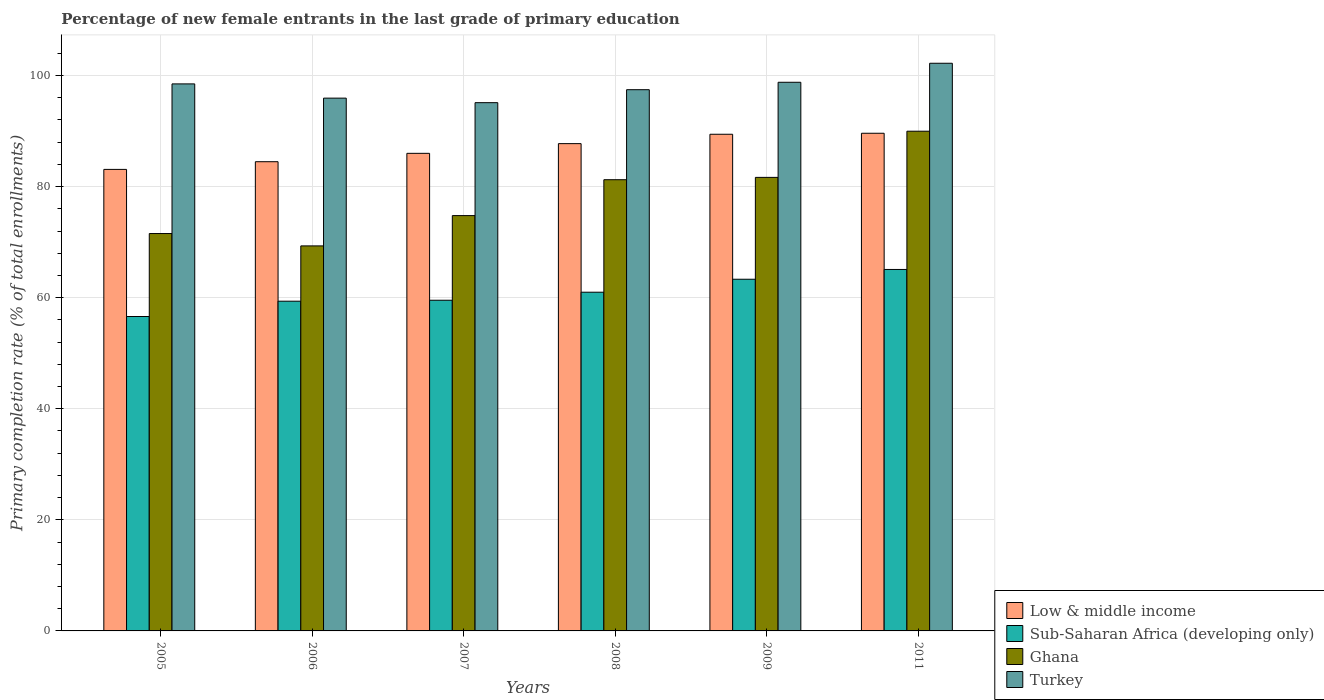Are the number of bars on each tick of the X-axis equal?
Offer a very short reply. Yes. How many bars are there on the 3rd tick from the left?
Give a very brief answer. 4. How many bars are there on the 2nd tick from the right?
Your answer should be compact. 4. What is the label of the 3rd group of bars from the left?
Make the answer very short. 2007. In how many cases, is the number of bars for a given year not equal to the number of legend labels?
Offer a terse response. 0. What is the percentage of new female entrants in Low & middle income in 2006?
Offer a very short reply. 84.48. Across all years, what is the maximum percentage of new female entrants in Low & middle income?
Your answer should be very brief. 89.6. Across all years, what is the minimum percentage of new female entrants in Turkey?
Offer a very short reply. 95.11. In which year was the percentage of new female entrants in Turkey minimum?
Give a very brief answer. 2007. What is the total percentage of new female entrants in Low & middle income in the graph?
Your answer should be very brief. 520.33. What is the difference between the percentage of new female entrants in Turkey in 2007 and that in 2009?
Your answer should be compact. -3.67. What is the difference between the percentage of new female entrants in Turkey in 2008 and the percentage of new female entrants in Low & middle income in 2005?
Provide a succinct answer. 14.35. What is the average percentage of new female entrants in Low & middle income per year?
Your response must be concise. 86.72. In the year 2008, what is the difference between the percentage of new female entrants in Low & middle income and percentage of new female entrants in Sub-Saharan Africa (developing only)?
Provide a short and direct response. 26.75. What is the ratio of the percentage of new female entrants in Ghana in 2005 to that in 2011?
Provide a short and direct response. 0.8. Is the difference between the percentage of new female entrants in Low & middle income in 2007 and 2008 greater than the difference between the percentage of new female entrants in Sub-Saharan Africa (developing only) in 2007 and 2008?
Keep it short and to the point. No. What is the difference between the highest and the second highest percentage of new female entrants in Sub-Saharan Africa (developing only)?
Ensure brevity in your answer.  1.76. What is the difference between the highest and the lowest percentage of new female entrants in Turkey?
Keep it short and to the point. 7.1. Is the sum of the percentage of new female entrants in Low & middle income in 2005 and 2008 greater than the maximum percentage of new female entrants in Ghana across all years?
Your answer should be compact. Yes. What does the 1st bar from the left in 2009 represents?
Your answer should be very brief. Low & middle income. How many bars are there?
Your answer should be very brief. 24. Are all the bars in the graph horizontal?
Your response must be concise. No. How many years are there in the graph?
Provide a succinct answer. 6. What is the difference between two consecutive major ticks on the Y-axis?
Ensure brevity in your answer.  20. Does the graph contain any zero values?
Provide a succinct answer. No. How are the legend labels stacked?
Keep it short and to the point. Vertical. What is the title of the graph?
Your answer should be very brief. Percentage of new female entrants in the last grade of primary education. What is the label or title of the X-axis?
Offer a very short reply. Years. What is the label or title of the Y-axis?
Offer a terse response. Primary completion rate (% of total enrollments). What is the Primary completion rate (% of total enrollments) in Low & middle income in 2005?
Offer a terse response. 83.1. What is the Primary completion rate (% of total enrollments) in Sub-Saharan Africa (developing only) in 2005?
Ensure brevity in your answer.  56.61. What is the Primary completion rate (% of total enrollments) in Ghana in 2005?
Give a very brief answer. 71.55. What is the Primary completion rate (% of total enrollments) of Turkey in 2005?
Your response must be concise. 98.49. What is the Primary completion rate (% of total enrollments) of Low & middle income in 2006?
Your answer should be very brief. 84.48. What is the Primary completion rate (% of total enrollments) in Sub-Saharan Africa (developing only) in 2006?
Offer a terse response. 59.37. What is the Primary completion rate (% of total enrollments) in Ghana in 2006?
Your response must be concise. 69.32. What is the Primary completion rate (% of total enrollments) of Turkey in 2006?
Offer a terse response. 95.93. What is the Primary completion rate (% of total enrollments) of Low & middle income in 2007?
Offer a terse response. 85.99. What is the Primary completion rate (% of total enrollments) in Sub-Saharan Africa (developing only) in 2007?
Offer a terse response. 59.54. What is the Primary completion rate (% of total enrollments) in Ghana in 2007?
Offer a very short reply. 74.78. What is the Primary completion rate (% of total enrollments) of Turkey in 2007?
Ensure brevity in your answer.  95.11. What is the Primary completion rate (% of total enrollments) in Low & middle income in 2008?
Offer a terse response. 87.74. What is the Primary completion rate (% of total enrollments) in Sub-Saharan Africa (developing only) in 2008?
Keep it short and to the point. 60.99. What is the Primary completion rate (% of total enrollments) in Ghana in 2008?
Your answer should be very brief. 81.24. What is the Primary completion rate (% of total enrollments) of Turkey in 2008?
Offer a very short reply. 97.45. What is the Primary completion rate (% of total enrollments) in Low & middle income in 2009?
Make the answer very short. 89.42. What is the Primary completion rate (% of total enrollments) of Sub-Saharan Africa (developing only) in 2009?
Keep it short and to the point. 63.32. What is the Primary completion rate (% of total enrollments) in Ghana in 2009?
Your response must be concise. 81.66. What is the Primary completion rate (% of total enrollments) of Turkey in 2009?
Offer a very short reply. 98.78. What is the Primary completion rate (% of total enrollments) of Low & middle income in 2011?
Provide a succinct answer. 89.6. What is the Primary completion rate (% of total enrollments) in Sub-Saharan Africa (developing only) in 2011?
Provide a short and direct response. 65.08. What is the Primary completion rate (% of total enrollments) of Ghana in 2011?
Provide a succinct answer. 89.97. What is the Primary completion rate (% of total enrollments) of Turkey in 2011?
Ensure brevity in your answer.  102.21. Across all years, what is the maximum Primary completion rate (% of total enrollments) of Low & middle income?
Provide a succinct answer. 89.6. Across all years, what is the maximum Primary completion rate (% of total enrollments) in Sub-Saharan Africa (developing only)?
Your response must be concise. 65.08. Across all years, what is the maximum Primary completion rate (% of total enrollments) of Ghana?
Offer a terse response. 89.97. Across all years, what is the maximum Primary completion rate (% of total enrollments) in Turkey?
Your answer should be very brief. 102.21. Across all years, what is the minimum Primary completion rate (% of total enrollments) of Low & middle income?
Provide a short and direct response. 83.1. Across all years, what is the minimum Primary completion rate (% of total enrollments) in Sub-Saharan Africa (developing only)?
Your answer should be compact. 56.61. Across all years, what is the minimum Primary completion rate (% of total enrollments) of Ghana?
Your response must be concise. 69.32. Across all years, what is the minimum Primary completion rate (% of total enrollments) in Turkey?
Your response must be concise. 95.11. What is the total Primary completion rate (% of total enrollments) in Low & middle income in the graph?
Offer a very short reply. 520.33. What is the total Primary completion rate (% of total enrollments) in Sub-Saharan Africa (developing only) in the graph?
Keep it short and to the point. 364.9. What is the total Primary completion rate (% of total enrollments) of Ghana in the graph?
Ensure brevity in your answer.  468.52. What is the total Primary completion rate (% of total enrollments) of Turkey in the graph?
Ensure brevity in your answer.  587.97. What is the difference between the Primary completion rate (% of total enrollments) of Low & middle income in 2005 and that in 2006?
Offer a terse response. -1.38. What is the difference between the Primary completion rate (% of total enrollments) in Sub-Saharan Africa (developing only) in 2005 and that in 2006?
Provide a short and direct response. -2.76. What is the difference between the Primary completion rate (% of total enrollments) of Ghana in 2005 and that in 2006?
Give a very brief answer. 2.22. What is the difference between the Primary completion rate (% of total enrollments) in Turkey in 2005 and that in 2006?
Your answer should be compact. 2.56. What is the difference between the Primary completion rate (% of total enrollments) of Low & middle income in 2005 and that in 2007?
Offer a terse response. -2.89. What is the difference between the Primary completion rate (% of total enrollments) of Sub-Saharan Africa (developing only) in 2005 and that in 2007?
Give a very brief answer. -2.93. What is the difference between the Primary completion rate (% of total enrollments) in Ghana in 2005 and that in 2007?
Offer a terse response. -3.23. What is the difference between the Primary completion rate (% of total enrollments) in Turkey in 2005 and that in 2007?
Provide a succinct answer. 3.38. What is the difference between the Primary completion rate (% of total enrollments) in Low & middle income in 2005 and that in 2008?
Give a very brief answer. -4.64. What is the difference between the Primary completion rate (% of total enrollments) of Sub-Saharan Africa (developing only) in 2005 and that in 2008?
Offer a terse response. -4.38. What is the difference between the Primary completion rate (% of total enrollments) in Ghana in 2005 and that in 2008?
Offer a very short reply. -9.69. What is the difference between the Primary completion rate (% of total enrollments) in Turkey in 2005 and that in 2008?
Offer a very short reply. 1.04. What is the difference between the Primary completion rate (% of total enrollments) in Low & middle income in 2005 and that in 2009?
Your answer should be very brief. -6.33. What is the difference between the Primary completion rate (% of total enrollments) in Sub-Saharan Africa (developing only) in 2005 and that in 2009?
Your response must be concise. -6.71. What is the difference between the Primary completion rate (% of total enrollments) of Ghana in 2005 and that in 2009?
Provide a succinct answer. -10.11. What is the difference between the Primary completion rate (% of total enrollments) in Turkey in 2005 and that in 2009?
Offer a very short reply. -0.29. What is the difference between the Primary completion rate (% of total enrollments) in Low & middle income in 2005 and that in 2011?
Offer a terse response. -6.51. What is the difference between the Primary completion rate (% of total enrollments) in Sub-Saharan Africa (developing only) in 2005 and that in 2011?
Keep it short and to the point. -8.47. What is the difference between the Primary completion rate (% of total enrollments) of Ghana in 2005 and that in 2011?
Your answer should be compact. -18.42. What is the difference between the Primary completion rate (% of total enrollments) of Turkey in 2005 and that in 2011?
Give a very brief answer. -3.72. What is the difference between the Primary completion rate (% of total enrollments) of Low & middle income in 2006 and that in 2007?
Offer a terse response. -1.51. What is the difference between the Primary completion rate (% of total enrollments) of Sub-Saharan Africa (developing only) in 2006 and that in 2007?
Your answer should be compact. -0.17. What is the difference between the Primary completion rate (% of total enrollments) of Ghana in 2006 and that in 2007?
Provide a succinct answer. -5.46. What is the difference between the Primary completion rate (% of total enrollments) in Turkey in 2006 and that in 2007?
Make the answer very short. 0.82. What is the difference between the Primary completion rate (% of total enrollments) in Low & middle income in 2006 and that in 2008?
Your answer should be very brief. -3.26. What is the difference between the Primary completion rate (% of total enrollments) of Sub-Saharan Africa (developing only) in 2006 and that in 2008?
Your answer should be compact. -1.62. What is the difference between the Primary completion rate (% of total enrollments) of Ghana in 2006 and that in 2008?
Ensure brevity in your answer.  -11.92. What is the difference between the Primary completion rate (% of total enrollments) of Turkey in 2006 and that in 2008?
Make the answer very short. -1.52. What is the difference between the Primary completion rate (% of total enrollments) in Low & middle income in 2006 and that in 2009?
Provide a short and direct response. -4.94. What is the difference between the Primary completion rate (% of total enrollments) of Sub-Saharan Africa (developing only) in 2006 and that in 2009?
Make the answer very short. -3.95. What is the difference between the Primary completion rate (% of total enrollments) in Ghana in 2006 and that in 2009?
Provide a succinct answer. -12.34. What is the difference between the Primary completion rate (% of total enrollments) in Turkey in 2006 and that in 2009?
Offer a very short reply. -2.86. What is the difference between the Primary completion rate (% of total enrollments) of Low & middle income in 2006 and that in 2011?
Your answer should be very brief. -5.12. What is the difference between the Primary completion rate (% of total enrollments) in Sub-Saharan Africa (developing only) in 2006 and that in 2011?
Your response must be concise. -5.71. What is the difference between the Primary completion rate (% of total enrollments) in Ghana in 2006 and that in 2011?
Your response must be concise. -20.65. What is the difference between the Primary completion rate (% of total enrollments) in Turkey in 2006 and that in 2011?
Provide a succinct answer. -6.28. What is the difference between the Primary completion rate (% of total enrollments) in Low & middle income in 2007 and that in 2008?
Keep it short and to the point. -1.75. What is the difference between the Primary completion rate (% of total enrollments) in Sub-Saharan Africa (developing only) in 2007 and that in 2008?
Ensure brevity in your answer.  -1.45. What is the difference between the Primary completion rate (% of total enrollments) of Ghana in 2007 and that in 2008?
Your answer should be very brief. -6.46. What is the difference between the Primary completion rate (% of total enrollments) of Turkey in 2007 and that in 2008?
Your answer should be compact. -2.34. What is the difference between the Primary completion rate (% of total enrollments) of Low & middle income in 2007 and that in 2009?
Offer a very short reply. -3.43. What is the difference between the Primary completion rate (% of total enrollments) in Sub-Saharan Africa (developing only) in 2007 and that in 2009?
Ensure brevity in your answer.  -3.78. What is the difference between the Primary completion rate (% of total enrollments) in Ghana in 2007 and that in 2009?
Offer a terse response. -6.88. What is the difference between the Primary completion rate (% of total enrollments) in Turkey in 2007 and that in 2009?
Your answer should be very brief. -3.67. What is the difference between the Primary completion rate (% of total enrollments) of Low & middle income in 2007 and that in 2011?
Make the answer very short. -3.61. What is the difference between the Primary completion rate (% of total enrollments) of Sub-Saharan Africa (developing only) in 2007 and that in 2011?
Offer a very short reply. -5.54. What is the difference between the Primary completion rate (% of total enrollments) in Ghana in 2007 and that in 2011?
Your answer should be very brief. -15.19. What is the difference between the Primary completion rate (% of total enrollments) in Turkey in 2007 and that in 2011?
Provide a short and direct response. -7.09. What is the difference between the Primary completion rate (% of total enrollments) in Low & middle income in 2008 and that in 2009?
Keep it short and to the point. -1.69. What is the difference between the Primary completion rate (% of total enrollments) in Sub-Saharan Africa (developing only) in 2008 and that in 2009?
Give a very brief answer. -2.33. What is the difference between the Primary completion rate (% of total enrollments) in Ghana in 2008 and that in 2009?
Your answer should be very brief. -0.42. What is the difference between the Primary completion rate (% of total enrollments) of Turkey in 2008 and that in 2009?
Ensure brevity in your answer.  -1.34. What is the difference between the Primary completion rate (% of total enrollments) of Low & middle income in 2008 and that in 2011?
Provide a succinct answer. -1.87. What is the difference between the Primary completion rate (% of total enrollments) in Sub-Saharan Africa (developing only) in 2008 and that in 2011?
Keep it short and to the point. -4.1. What is the difference between the Primary completion rate (% of total enrollments) of Ghana in 2008 and that in 2011?
Provide a short and direct response. -8.73. What is the difference between the Primary completion rate (% of total enrollments) in Turkey in 2008 and that in 2011?
Offer a terse response. -4.76. What is the difference between the Primary completion rate (% of total enrollments) in Low & middle income in 2009 and that in 2011?
Your response must be concise. -0.18. What is the difference between the Primary completion rate (% of total enrollments) in Sub-Saharan Africa (developing only) in 2009 and that in 2011?
Keep it short and to the point. -1.76. What is the difference between the Primary completion rate (% of total enrollments) in Ghana in 2009 and that in 2011?
Provide a short and direct response. -8.31. What is the difference between the Primary completion rate (% of total enrollments) of Turkey in 2009 and that in 2011?
Offer a terse response. -3.42. What is the difference between the Primary completion rate (% of total enrollments) in Low & middle income in 2005 and the Primary completion rate (% of total enrollments) in Sub-Saharan Africa (developing only) in 2006?
Your answer should be very brief. 23.73. What is the difference between the Primary completion rate (% of total enrollments) in Low & middle income in 2005 and the Primary completion rate (% of total enrollments) in Ghana in 2006?
Your answer should be compact. 13.77. What is the difference between the Primary completion rate (% of total enrollments) in Low & middle income in 2005 and the Primary completion rate (% of total enrollments) in Turkey in 2006?
Your answer should be compact. -12.83. What is the difference between the Primary completion rate (% of total enrollments) in Sub-Saharan Africa (developing only) in 2005 and the Primary completion rate (% of total enrollments) in Ghana in 2006?
Provide a short and direct response. -12.71. What is the difference between the Primary completion rate (% of total enrollments) in Sub-Saharan Africa (developing only) in 2005 and the Primary completion rate (% of total enrollments) in Turkey in 2006?
Your response must be concise. -39.32. What is the difference between the Primary completion rate (% of total enrollments) of Ghana in 2005 and the Primary completion rate (% of total enrollments) of Turkey in 2006?
Provide a short and direct response. -24.38. What is the difference between the Primary completion rate (% of total enrollments) in Low & middle income in 2005 and the Primary completion rate (% of total enrollments) in Sub-Saharan Africa (developing only) in 2007?
Give a very brief answer. 23.56. What is the difference between the Primary completion rate (% of total enrollments) of Low & middle income in 2005 and the Primary completion rate (% of total enrollments) of Ghana in 2007?
Keep it short and to the point. 8.32. What is the difference between the Primary completion rate (% of total enrollments) of Low & middle income in 2005 and the Primary completion rate (% of total enrollments) of Turkey in 2007?
Offer a very short reply. -12.01. What is the difference between the Primary completion rate (% of total enrollments) in Sub-Saharan Africa (developing only) in 2005 and the Primary completion rate (% of total enrollments) in Ghana in 2007?
Provide a succinct answer. -18.17. What is the difference between the Primary completion rate (% of total enrollments) of Sub-Saharan Africa (developing only) in 2005 and the Primary completion rate (% of total enrollments) of Turkey in 2007?
Provide a short and direct response. -38.5. What is the difference between the Primary completion rate (% of total enrollments) in Ghana in 2005 and the Primary completion rate (% of total enrollments) in Turkey in 2007?
Keep it short and to the point. -23.57. What is the difference between the Primary completion rate (% of total enrollments) of Low & middle income in 2005 and the Primary completion rate (% of total enrollments) of Sub-Saharan Africa (developing only) in 2008?
Your response must be concise. 22.11. What is the difference between the Primary completion rate (% of total enrollments) in Low & middle income in 2005 and the Primary completion rate (% of total enrollments) in Ghana in 2008?
Offer a terse response. 1.86. What is the difference between the Primary completion rate (% of total enrollments) in Low & middle income in 2005 and the Primary completion rate (% of total enrollments) in Turkey in 2008?
Make the answer very short. -14.35. What is the difference between the Primary completion rate (% of total enrollments) of Sub-Saharan Africa (developing only) in 2005 and the Primary completion rate (% of total enrollments) of Ghana in 2008?
Keep it short and to the point. -24.63. What is the difference between the Primary completion rate (% of total enrollments) of Sub-Saharan Africa (developing only) in 2005 and the Primary completion rate (% of total enrollments) of Turkey in 2008?
Give a very brief answer. -40.84. What is the difference between the Primary completion rate (% of total enrollments) in Ghana in 2005 and the Primary completion rate (% of total enrollments) in Turkey in 2008?
Your answer should be very brief. -25.9. What is the difference between the Primary completion rate (% of total enrollments) in Low & middle income in 2005 and the Primary completion rate (% of total enrollments) in Sub-Saharan Africa (developing only) in 2009?
Offer a very short reply. 19.78. What is the difference between the Primary completion rate (% of total enrollments) in Low & middle income in 2005 and the Primary completion rate (% of total enrollments) in Ghana in 2009?
Offer a very short reply. 1.44. What is the difference between the Primary completion rate (% of total enrollments) in Low & middle income in 2005 and the Primary completion rate (% of total enrollments) in Turkey in 2009?
Make the answer very short. -15.69. What is the difference between the Primary completion rate (% of total enrollments) of Sub-Saharan Africa (developing only) in 2005 and the Primary completion rate (% of total enrollments) of Ghana in 2009?
Give a very brief answer. -25.05. What is the difference between the Primary completion rate (% of total enrollments) in Sub-Saharan Africa (developing only) in 2005 and the Primary completion rate (% of total enrollments) in Turkey in 2009?
Your response must be concise. -42.18. What is the difference between the Primary completion rate (% of total enrollments) of Ghana in 2005 and the Primary completion rate (% of total enrollments) of Turkey in 2009?
Your answer should be very brief. -27.24. What is the difference between the Primary completion rate (% of total enrollments) in Low & middle income in 2005 and the Primary completion rate (% of total enrollments) in Sub-Saharan Africa (developing only) in 2011?
Offer a very short reply. 18.02. What is the difference between the Primary completion rate (% of total enrollments) in Low & middle income in 2005 and the Primary completion rate (% of total enrollments) in Ghana in 2011?
Make the answer very short. -6.87. What is the difference between the Primary completion rate (% of total enrollments) of Low & middle income in 2005 and the Primary completion rate (% of total enrollments) of Turkey in 2011?
Your response must be concise. -19.11. What is the difference between the Primary completion rate (% of total enrollments) in Sub-Saharan Africa (developing only) in 2005 and the Primary completion rate (% of total enrollments) in Ghana in 2011?
Your answer should be very brief. -33.36. What is the difference between the Primary completion rate (% of total enrollments) of Sub-Saharan Africa (developing only) in 2005 and the Primary completion rate (% of total enrollments) of Turkey in 2011?
Provide a short and direct response. -45.6. What is the difference between the Primary completion rate (% of total enrollments) in Ghana in 2005 and the Primary completion rate (% of total enrollments) in Turkey in 2011?
Ensure brevity in your answer.  -30.66. What is the difference between the Primary completion rate (% of total enrollments) in Low & middle income in 2006 and the Primary completion rate (% of total enrollments) in Sub-Saharan Africa (developing only) in 2007?
Offer a very short reply. 24.94. What is the difference between the Primary completion rate (% of total enrollments) of Low & middle income in 2006 and the Primary completion rate (% of total enrollments) of Ghana in 2007?
Provide a succinct answer. 9.7. What is the difference between the Primary completion rate (% of total enrollments) of Low & middle income in 2006 and the Primary completion rate (% of total enrollments) of Turkey in 2007?
Provide a short and direct response. -10.63. What is the difference between the Primary completion rate (% of total enrollments) in Sub-Saharan Africa (developing only) in 2006 and the Primary completion rate (% of total enrollments) in Ghana in 2007?
Keep it short and to the point. -15.41. What is the difference between the Primary completion rate (% of total enrollments) in Sub-Saharan Africa (developing only) in 2006 and the Primary completion rate (% of total enrollments) in Turkey in 2007?
Provide a succinct answer. -35.74. What is the difference between the Primary completion rate (% of total enrollments) in Ghana in 2006 and the Primary completion rate (% of total enrollments) in Turkey in 2007?
Offer a terse response. -25.79. What is the difference between the Primary completion rate (% of total enrollments) in Low & middle income in 2006 and the Primary completion rate (% of total enrollments) in Sub-Saharan Africa (developing only) in 2008?
Your answer should be compact. 23.49. What is the difference between the Primary completion rate (% of total enrollments) in Low & middle income in 2006 and the Primary completion rate (% of total enrollments) in Ghana in 2008?
Provide a short and direct response. 3.24. What is the difference between the Primary completion rate (% of total enrollments) in Low & middle income in 2006 and the Primary completion rate (% of total enrollments) in Turkey in 2008?
Provide a short and direct response. -12.97. What is the difference between the Primary completion rate (% of total enrollments) of Sub-Saharan Africa (developing only) in 2006 and the Primary completion rate (% of total enrollments) of Ghana in 2008?
Make the answer very short. -21.87. What is the difference between the Primary completion rate (% of total enrollments) of Sub-Saharan Africa (developing only) in 2006 and the Primary completion rate (% of total enrollments) of Turkey in 2008?
Ensure brevity in your answer.  -38.08. What is the difference between the Primary completion rate (% of total enrollments) of Ghana in 2006 and the Primary completion rate (% of total enrollments) of Turkey in 2008?
Give a very brief answer. -28.12. What is the difference between the Primary completion rate (% of total enrollments) of Low & middle income in 2006 and the Primary completion rate (% of total enrollments) of Sub-Saharan Africa (developing only) in 2009?
Your response must be concise. 21.16. What is the difference between the Primary completion rate (% of total enrollments) of Low & middle income in 2006 and the Primary completion rate (% of total enrollments) of Ghana in 2009?
Make the answer very short. 2.82. What is the difference between the Primary completion rate (% of total enrollments) in Low & middle income in 2006 and the Primary completion rate (% of total enrollments) in Turkey in 2009?
Offer a terse response. -14.3. What is the difference between the Primary completion rate (% of total enrollments) in Sub-Saharan Africa (developing only) in 2006 and the Primary completion rate (% of total enrollments) in Ghana in 2009?
Make the answer very short. -22.29. What is the difference between the Primary completion rate (% of total enrollments) of Sub-Saharan Africa (developing only) in 2006 and the Primary completion rate (% of total enrollments) of Turkey in 2009?
Offer a terse response. -39.42. What is the difference between the Primary completion rate (% of total enrollments) of Ghana in 2006 and the Primary completion rate (% of total enrollments) of Turkey in 2009?
Provide a succinct answer. -29.46. What is the difference between the Primary completion rate (% of total enrollments) in Low & middle income in 2006 and the Primary completion rate (% of total enrollments) in Sub-Saharan Africa (developing only) in 2011?
Ensure brevity in your answer.  19.4. What is the difference between the Primary completion rate (% of total enrollments) in Low & middle income in 2006 and the Primary completion rate (% of total enrollments) in Ghana in 2011?
Give a very brief answer. -5.49. What is the difference between the Primary completion rate (% of total enrollments) of Low & middle income in 2006 and the Primary completion rate (% of total enrollments) of Turkey in 2011?
Make the answer very short. -17.73. What is the difference between the Primary completion rate (% of total enrollments) of Sub-Saharan Africa (developing only) in 2006 and the Primary completion rate (% of total enrollments) of Ghana in 2011?
Provide a succinct answer. -30.6. What is the difference between the Primary completion rate (% of total enrollments) in Sub-Saharan Africa (developing only) in 2006 and the Primary completion rate (% of total enrollments) in Turkey in 2011?
Provide a succinct answer. -42.84. What is the difference between the Primary completion rate (% of total enrollments) in Ghana in 2006 and the Primary completion rate (% of total enrollments) in Turkey in 2011?
Make the answer very short. -32.88. What is the difference between the Primary completion rate (% of total enrollments) of Low & middle income in 2007 and the Primary completion rate (% of total enrollments) of Sub-Saharan Africa (developing only) in 2008?
Your answer should be very brief. 25. What is the difference between the Primary completion rate (% of total enrollments) of Low & middle income in 2007 and the Primary completion rate (% of total enrollments) of Ghana in 2008?
Provide a short and direct response. 4.75. What is the difference between the Primary completion rate (% of total enrollments) of Low & middle income in 2007 and the Primary completion rate (% of total enrollments) of Turkey in 2008?
Offer a terse response. -11.46. What is the difference between the Primary completion rate (% of total enrollments) of Sub-Saharan Africa (developing only) in 2007 and the Primary completion rate (% of total enrollments) of Ghana in 2008?
Give a very brief answer. -21.7. What is the difference between the Primary completion rate (% of total enrollments) of Sub-Saharan Africa (developing only) in 2007 and the Primary completion rate (% of total enrollments) of Turkey in 2008?
Make the answer very short. -37.91. What is the difference between the Primary completion rate (% of total enrollments) in Ghana in 2007 and the Primary completion rate (% of total enrollments) in Turkey in 2008?
Keep it short and to the point. -22.67. What is the difference between the Primary completion rate (% of total enrollments) of Low & middle income in 2007 and the Primary completion rate (% of total enrollments) of Sub-Saharan Africa (developing only) in 2009?
Provide a succinct answer. 22.67. What is the difference between the Primary completion rate (% of total enrollments) of Low & middle income in 2007 and the Primary completion rate (% of total enrollments) of Ghana in 2009?
Ensure brevity in your answer.  4.33. What is the difference between the Primary completion rate (% of total enrollments) in Low & middle income in 2007 and the Primary completion rate (% of total enrollments) in Turkey in 2009?
Keep it short and to the point. -12.8. What is the difference between the Primary completion rate (% of total enrollments) of Sub-Saharan Africa (developing only) in 2007 and the Primary completion rate (% of total enrollments) of Ghana in 2009?
Your answer should be compact. -22.12. What is the difference between the Primary completion rate (% of total enrollments) in Sub-Saharan Africa (developing only) in 2007 and the Primary completion rate (% of total enrollments) in Turkey in 2009?
Your answer should be compact. -39.25. What is the difference between the Primary completion rate (% of total enrollments) in Ghana in 2007 and the Primary completion rate (% of total enrollments) in Turkey in 2009?
Offer a very short reply. -24.01. What is the difference between the Primary completion rate (% of total enrollments) of Low & middle income in 2007 and the Primary completion rate (% of total enrollments) of Sub-Saharan Africa (developing only) in 2011?
Ensure brevity in your answer.  20.91. What is the difference between the Primary completion rate (% of total enrollments) in Low & middle income in 2007 and the Primary completion rate (% of total enrollments) in Ghana in 2011?
Ensure brevity in your answer.  -3.98. What is the difference between the Primary completion rate (% of total enrollments) of Low & middle income in 2007 and the Primary completion rate (% of total enrollments) of Turkey in 2011?
Offer a very short reply. -16.22. What is the difference between the Primary completion rate (% of total enrollments) of Sub-Saharan Africa (developing only) in 2007 and the Primary completion rate (% of total enrollments) of Ghana in 2011?
Keep it short and to the point. -30.43. What is the difference between the Primary completion rate (% of total enrollments) in Sub-Saharan Africa (developing only) in 2007 and the Primary completion rate (% of total enrollments) in Turkey in 2011?
Your answer should be very brief. -42.67. What is the difference between the Primary completion rate (% of total enrollments) in Ghana in 2007 and the Primary completion rate (% of total enrollments) in Turkey in 2011?
Offer a terse response. -27.43. What is the difference between the Primary completion rate (% of total enrollments) in Low & middle income in 2008 and the Primary completion rate (% of total enrollments) in Sub-Saharan Africa (developing only) in 2009?
Offer a very short reply. 24.42. What is the difference between the Primary completion rate (% of total enrollments) in Low & middle income in 2008 and the Primary completion rate (% of total enrollments) in Ghana in 2009?
Provide a succinct answer. 6.08. What is the difference between the Primary completion rate (% of total enrollments) in Low & middle income in 2008 and the Primary completion rate (% of total enrollments) in Turkey in 2009?
Offer a very short reply. -11.05. What is the difference between the Primary completion rate (% of total enrollments) in Sub-Saharan Africa (developing only) in 2008 and the Primary completion rate (% of total enrollments) in Ghana in 2009?
Ensure brevity in your answer.  -20.67. What is the difference between the Primary completion rate (% of total enrollments) in Sub-Saharan Africa (developing only) in 2008 and the Primary completion rate (% of total enrollments) in Turkey in 2009?
Keep it short and to the point. -37.8. What is the difference between the Primary completion rate (% of total enrollments) in Ghana in 2008 and the Primary completion rate (% of total enrollments) in Turkey in 2009?
Your answer should be compact. -17.55. What is the difference between the Primary completion rate (% of total enrollments) in Low & middle income in 2008 and the Primary completion rate (% of total enrollments) in Sub-Saharan Africa (developing only) in 2011?
Your answer should be very brief. 22.65. What is the difference between the Primary completion rate (% of total enrollments) in Low & middle income in 2008 and the Primary completion rate (% of total enrollments) in Ghana in 2011?
Make the answer very short. -2.24. What is the difference between the Primary completion rate (% of total enrollments) in Low & middle income in 2008 and the Primary completion rate (% of total enrollments) in Turkey in 2011?
Provide a short and direct response. -14.47. What is the difference between the Primary completion rate (% of total enrollments) in Sub-Saharan Africa (developing only) in 2008 and the Primary completion rate (% of total enrollments) in Ghana in 2011?
Provide a short and direct response. -28.99. What is the difference between the Primary completion rate (% of total enrollments) in Sub-Saharan Africa (developing only) in 2008 and the Primary completion rate (% of total enrollments) in Turkey in 2011?
Provide a short and direct response. -41.22. What is the difference between the Primary completion rate (% of total enrollments) of Ghana in 2008 and the Primary completion rate (% of total enrollments) of Turkey in 2011?
Ensure brevity in your answer.  -20.97. What is the difference between the Primary completion rate (% of total enrollments) of Low & middle income in 2009 and the Primary completion rate (% of total enrollments) of Sub-Saharan Africa (developing only) in 2011?
Provide a succinct answer. 24.34. What is the difference between the Primary completion rate (% of total enrollments) of Low & middle income in 2009 and the Primary completion rate (% of total enrollments) of Ghana in 2011?
Give a very brief answer. -0.55. What is the difference between the Primary completion rate (% of total enrollments) in Low & middle income in 2009 and the Primary completion rate (% of total enrollments) in Turkey in 2011?
Your answer should be compact. -12.78. What is the difference between the Primary completion rate (% of total enrollments) of Sub-Saharan Africa (developing only) in 2009 and the Primary completion rate (% of total enrollments) of Ghana in 2011?
Keep it short and to the point. -26.65. What is the difference between the Primary completion rate (% of total enrollments) in Sub-Saharan Africa (developing only) in 2009 and the Primary completion rate (% of total enrollments) in Turkey in 2011?
Make the answer very short. -38.89. What is the difference between the Primary completion rate (% of total enrollments) of Ghana in 2009 and the Primary completion rate (% of total enrollments) of Turkey in 2011?
Provide a short and direct response. -20.55. What is the average Primary completion rate (% of total enrollments) in Low & middle income per year?
Make the answer very short. 86.72. What is the average Primary completion rate (% of total enrollments) of Sub-Saharan Africa (developing only) per year?
Your response must be concise. 60.82. What is the average Primary completion rate (% of total enrollments) of Ghana per year?
Make the answer very short. 78.09. What is the average Primary completion rate (% of total enrollments) in Turkey per year?
Offer a terse response. 98. In the year 2005, what is the difference between the Primary completion rate (% of total enrollments) of Low & middle income and Primary completion rate (% of total enrollments) of Sub-Saharan Africa (developing only)?
Give a very brief answer. 26.49. In the year 2005, what is the difference between the Primary completion rate (% of total enrollments) of Low & middle income and Primary completion rate (% of total enrollments) of Ghana?
Your response must be concise. 11.55. In the year 2005, what is the difference between the Primary completion rate (% of total enrollments) in Low & middle income and Primary completion rate (% of total enrollments) in Turkey?
Offer a very short reply. -15.39. In the year 2005, what is the difference between the Primary completion rate (% of total enrollments) of Sub-Saharan Africa (developing only) and Primary completion rate (% of total enrollments) of Ghana?
Offer a terse response. -14.94. In the year 2005, what is the difference between the Primary completion rate (% of total enrollments) in Sub-Saharan Africa (developing only) and Primary completion rate (% of total enrollments) in Turkey?
Offer a terse response. -41.88. In the year 2005, what is the difference between the Primary completion rate (% of total enrollments) of Ghana and Primary completion rate (% of total enrollments) of Turkey?
Give a very brief answer. -26.95. In the year 2006, what is the difference between the Primary completion rate (% of total enrollments) in Low & middle income and Primary completion rate (% of total enrollments) in Sub-Saharan Africa (developing only)?
Ensure brevity in your answer.  25.11. In the year 2006, what is the difference between the Primary completion rate (% of total enrollments) of Low & middle income and Primary completion rate (% of total enrollments) of Ghana?
Make the answer very short. 15.16. In the year 2006, what is the difference between the Primary completion rate (% of total enrollments) in Low & middle income and Primary completion rate (% of total enrollments) in Turkey?
Your answer should be compact. -11.45. In the year 2006, what is the difference between the Primary completion rate (% of total enrollments) of Sub-Saharan Africa (developing only) and Primary completion rate (% of total enrollments) of Ghana?
Make the answer very short. -9.96. In the year 2006, what is the difference between the Primary completion rate (% of total enrollments) in Sub-Saharan Africa (developing only) and Primary completion rate (% of total enrollments) in Turkey?
Your answer should be very brief. -36.56. In the year 2006, what is the difference between the Primary completion rate (% of total enrollments) in Ghana and Primary completion rate (% of total enrollments) in Turkey?
Provide a short and direct response. -26.6. In the year 2007, what is the difference between the Primary completion rate (% of total enrollments) of Low & middle income and Primary completion rate (% of total enrollments) of Sub-Saharan Africa (developing only)?
Your answer should be very brief. 26.45. In the year 2007, what is the difference between the Primary completion rate (% of total enrollments) of Low & middle income and Primary completion rate (% of total enrollments) of Ghana?
Ensure brevity in your answer.  11.21. In the year 2007, what is the difference between the Primary completion rate (% of total enrollments) in Low & middle income and Primary completion rate (% of total enrollments) in Turkey?
Your answer should be compact. -9.12. In the year 2007, what is the difference between the Primary completion rate (% of total enrollments) in Sub-Saharan Africa (developing only) and Primary completion rate (% of total enrollments) in Ghana?
Offer a very short reply. -15.24. In the year 2007, what is the difference between the Primary completion rate (% of total enrollments) in Sub-Saharan Africa (developing only) and Primary completion rate (% of total enrollments) in Turkey?
Your answer should be very brief. -35.57. In the year 2007, what is the difference between the Primary completion rate (% of total enrollments) of Ghana and Primary completion rate (% of total enrollments) of Turkey?
Keep it short and to the point. -20.33. In the year 2008, what is the difference between the Primary completion rate (% of total enrollments) in Low & middle income and Primary completion rate (% of total enrollments) in Sub-Saharan Africa (developing only)?
Offer a terse response. 26.75. In the year 2008, what is the difference between the Primary completion rate (% of total enrollments) of Low & middle income and Primary completion rate (% of total enrollments) of Ghana?
Provide a succinct answer. 6.5. In the year 2008, what is the difference between the Primary completion rate (% of total enrollments) in Low & middle income and Primary completion rate (% of total enrollments) in Turkey?
Your answer should be compact. -9.71. In the year 2008, what is the difference between the Primary completion rate (% of total enrollments) in Sub-Saharan Africa (developing only) and Primary completion rate (% of total enrollments) in Ghana?
Provide a succinct answer. -20.25. In the year 2008, what is the difference between the Primary completion rate (% of total enrollments) of Sub-Saharan Africa (developing only) and Primary completion rate (% of total enrollments) of Turkey?
Ensure brevity in your answer.  -36.46. In the year 2008, what is the difference between the Primary completion rate (% of total enrollments) of Ghana and Primary completion rate (% of total enrollments) of Turkey?
Provide a succinct answer. -16.21. In the year 2009, what is the difference between the Primary completion rate (% of total enrollments) of Low & middle income and Primary completion rate (% of total enrollments) of Sub-Saharan Africa (developing only)?
Your response must be concise. 26.11. In the year 2009, what is the difference between the Primary completion rate (% of total enrollments) in Low & middle income and Primary completion rate (% of total enrollments) in Ghana?
Provide a succinct answer. 7.76. In the year 2009, what is the difference between the Primary completion rate (% of total enrollments) of Low & middle income and Primary completion rate (% of total enrollments) of Turkey?
Your answer should be compact. -9.36. In the year 2009, what is the difference between the Primary completion rate (% of total enrollments) in Sub-Saharan Africa (developing only) and Primary completion rate (% of total enrollments) in Ghana?
Keep it short and to the point. -18.34. In the year 2009, what is the difference between the Primary completion rate (% of total enrollments) in Sub-Saharan Africa (developing only) and Primary completion rate (% of total enrollments) in Turkey?
Make the answer very short. -35.47. In the year 2009, what is the difference between the Primary completion rate (% of total enrollments) in Ghana and Primary completion rate (% of total enrollments) in Turkey?
Provide a short and direct response. -17.12. In the year 2011, what is the difference between the Primary completion rate (% of total enrollments) of Low & middle income and Primary completion rate (% of total enrollments) of Sub-Saharan Africa (developing only)?
Make the answer very short. 24.52. In the year 2011, what is the difference between the Primary completion rate (% of total enrollments) in Low & middle income and Primary completion rate (% of total enrollments) in Ghana?
Your answer should be compact. -0.37. In the year 2011, what is the difference between the Primary completion rate (% of total enrollments) of Low & middle income and Primary completion rate (% of total enrollments) of Turkey?
Offer a very short reply. -12.6. In the year 2011, what is the difference between the Primary completion rate (% of total enrollments) of Sub-Saharan Africa (developing only) and Primary completion rate (% of total enrollments) of Ghana?
Keep it short and to the point. -24.89. In the year 2011, what is the difference between the Primary completion rate (% of total enrollments) of Sub-Saharan Africa (developing only) and Primary completion rate (% of total enrollments) of Turkey?
Ensure brevity in your answer.  -37.13. In the year 2011, what is the difference between the Primary completion rate (% of total enrollments) in Ghana and Primary completion rate (% of total enrollments) in Turkey?
Provide a short and direct response. -12.24. What is the ratio of the Primary completion rate (% of total enrollments) in Low & middle income in 2005 to that in 2006?
Ensure brevity in your answer.  0.98. What is the ratio of the Primary completion rate (% of total enrollments) of Sub-Saharan Africa (developing only) in 2005 to that in 2006?
Provide a short and direct response. 0.95. What is the ratio of the Primary completion rate (% of total enrollments) of Ghana in 2005 to that in 2006?
Provide a short and direct response. 1.03. What is the ratio of the Primary completion rate (% of total enrollments) in Turkey in 2005 to that in 2006?
Give a very brief answer. 1.03. What is the ratio of the Primary completion rate (% of total enrollments) in Low & middle income in 2005 to that in 2007?
Provide a short and direct response. 0.97. What is the ratio of the Primary completion rate (% of total enrollments) of Sub-Saharan Africa (developing only) in 2005 to that in 2007?
Provide a succinct answer. 0.95. What is the ratio of the Primary completion rate (% of total enrollments) in Ghana in 2005 to that in 2007?
Your response must be concise. 0.96. What is the ratio of the Primary completion rate (% of total enrollments) in Turkey in 2005 to that in 2007?
Keep it short and to the point. 1.04. What is the ratio of the Primary completion rate (% of total enrollments) of Low & middle income in 2005 to that in 2008?
Your answer should be compact. 0.95. What is the ratio of the Primary completion rate (% of total enrollments) of Sub-Saharan Africa (developing only) in 2005 to that in 2008?
Give a very brief answer. 0.93. What is the ratio of the Primary completion rate (% of total enrollments) in Ghana in 2005 to that in 2008?
Your answer should be very brief. 0.88. What is the ratio of the Primary completion rate (% of total enrollments) of Turkey in 2005 to that in 2008?
Provide a short and direct response. 1.01. What is the ratio of the Primary completion rate (% of total enrollments) of Low & middle income in 2005 to that in 2009?
Give a very brief answer. 0.93. What is the ratio of the Primary completion rate (% of total enrollments) of Sub-Saharan Africa (developing only) in 2005 to that in 2009?
Provide a succinct answer. 0.89. What is the ratio of the Primary completion rate (% of total enrollments) in Ghana in 2005 to that in 2009?
Make the answer very short. 0.88. What is the ratio of the Primary completion rate (% of total enrollments) in Low & middle income in 2005 to that in 2011?
Provide a succinct answer. 0.93. What is the ratio of the Primary completion rate (% of total enrollments) in Sub-Saharan Africa (developing only) in 2005 to that in 2011?
Your answer should be compact. 0.87. What is the ratio of the Primary completion rate (% of total enrollments) of Ghana in 2005 to that in 2011?
Ensure brevity in your answer.  0.8. What is the ratio of the Primary completion rate (% of total enrollments) in Turkey in 2005 to that in 2011?
Provide a succinct answer. 0.96. What is the ratio of the Primary completion rate (% of total enrollments) in Low & middle income in 2006 to that in 2007?
Provide a short and direct response. 0.98. What is the ratio of the Primary completion rate (% of total enrollments) of Sub-Saharan Africa (developing only) in 2006 to that in 2007?
Give a very brief answer. 1. What is the ratio of the Primary completion rate (% of total enrollments) in Ghana in 2006 to that in 2007?
Keep it short and to the point. 0.93. What is the ratio of the Primary completion rate (% of total enrollments) of Turkey in 2006 to that in 2007?
Give a very brief answer. 1.01. What is the ratio of the Primary completion rate (% of total enrollments) of Low & middle income in 2006 to that in 2008?
Your answer should be very brief. 0.96. What is the ratio of the Primary completion rate (% of total enrollments) in Sub-Saharan Africa (developing only) in 2006 to that in 2008?
Keep it short and to the point. 0.97. What is the ratio of the Primary completion rate (% of total enrollments) of Ghana in 2006 to that in 2008?
Ensure brevity in your answer.  0.85. What is the ratio of the Primary completion rate (% of total enrollments) in Turkey in 2006 to that in 2008?
Your response must be concise. 0.98. What is the ratio of the Primary completion rate (% of total enrollments) in Low & middle income in 2006 to that in 2009?
Keep it short and to the point. 0.94. What is the ratio of the Primary completion rate (% of total enrollments) of Sub-Saharan Africa (developing only) in 2006 to that in 2009?
Offer a terse response. 0.94. What is the ratio of the Primary completion rate (% of total enrollments) of Ghana in 2006 to that in 2009?
Offer a terse response. 0.85. What is the ratio of the Primary completion rate (% of total enrollments) in Turkey in 2006 to that in 2009?
Your answer should be compact. 0.97. What is the ratio of the Primary completion rate (% of total enrollments) in Low & middle income in 2006 to that in 2011?
Your answer should be very brief. 0.94. What is the ratio of the Primary completion rate (% of total enrollments) in Sub-Saharan Africa (developing only) in 2006 to that in 2011?
Keep it short and to the point. 0.91. What is the ratio of the Primary completion rate (% of total enrollments) in Ghana in 2006 to that in 2011?
Your response must be concise. 0.77. What is the ratio of the Primary completion rate (% of total enrollments) of Turkey in 2006 to that in 2011?
Provide a succinct answer. 0.94. What is the ratio of the Primary completion rate (% of total enrollments) of Low & middle income in 2007 to that in 2008?
Make the answer very short. 0.98. What is the ratio of the Primary completion rate (% of total enrollments) of Sub-Saharan Africa (developing only) in 2007 to that in 2008?
Keep it short and to the point. 0.98. What is the ratio of the Primary completion rate (% of total enrollments) in Ghana in 2007 to that in 2008?
Offer a very short reply. 0.92. What is the ratio of the Primary completion rate (% of total enrollments) of Turkey in 2007 to that in 2008?
Give a very brief answer. 0.98. What is the ratio of the Primary completion rate (% of total enrollments) in Low & middle income in 2007 to that in 2009?
Your answer should be very brief. 0.96. What is the ratio of the Primary completion rate (% of total enrollments) in Sub-Saharan Africa (developing only) in 2007 to that in 2009?
Offer a terse response. 0.94. What is the ratio of the Primary completion rate (% of total enrollments) in Ghana in 2007 to that in 2009?
Keep it short and to the point. 0.92. What is the ratio of the Primary completion rate (% of total enrollments) in Turkey in 2007 to that in 2009?
Your answer should be very brief. 0.96. What is the ratio of the Primary completion rate (% of total enrollments) in Low & middle income in 2007 to that in 2011?
Give a very brief answer. 0.96. What is the ratio of the Primary completion rate (% of total enrollments) in Sub-Saharan Africa (developing only) in 2007 to that in 2011?
Provide a short and direct response. 0.91. What is the ratio of the Primary completion rate (% of total enrollments) of Ghana in 2007 to that in 2011?
Give a very brief answer. 0.83. What is the ratio of the Primary completion rate (% of total enrollments) of Turkey in 2007 to that in 2011?
Provide a succinct answer. 0.93. What is the ratio of the Primary completion rate (% of total enrollments) of Low & middle income in 2008 to that in 2009?
Keep it short and to the point. 0.98. What is the ratio of the Primary completion rate (% of total enrollments) in Sub-Saharan Africa (developing only) in 2008 to that in 2009?
Provide a short and direct response. 0.96. What is the ratio of the Primary completion rate (% of total enrollments) in Ghana in 2008 to that in 2009?
Provide a short and direct response. 0.99. What is the ratio of the Primary completion rate (% of total enrollments) in Turkey in 2008 to that in 2009?
Provide a succinct answer. 0.99. What is the ratio of the Primary completion rate (% of total enrollments) of Low & middle income in 2008 to that in 2011?
Keep it short and to the point. 0.98. What is the ratio of the Primary completion rate (% of total enrollments) of Sub-Saharan Africa (developing only) in 2008 to that in 2011?
Make the answer very short. 0.94. What is the ratio of the Primary completion rate (% of total enrollments) of Ghana in 2008 to that in 2011?
Offer a very short reply. 0.9. What is the ratio of the Primary completion rate (% of total enrollments) of Turkey in 2008 to that in 2011?
Give a very brief answer. 0.95. What is the ratio of the Primary completion rate (% of total enrollments) of Sub-Saharan Africa (developing only) in 2009 to that in 2011?
Give a very brief answer. 0.97. What is the ratio of the Primary completion rate (% of total enrollments) in Ghana in 2009 to that in 2011?
Your answer should be very brief. 0.91. What is the ratio of the Primary completion rate (% of total enrollments) in Turkey in 2009 to that in 2011?
Your answer should be very brief. 0.97. What is the difference between the highest and the second highest Primary completion rate (% of total enrollments) in Low & middle income?
Provide a short and direct response. 0.18. What is the difference between the highest and the second highest Primary completion rate (% of total enrollments) in Sub-Saharan Africa (developing only)?
Provide a succinct answer. 1.76. What is the difference between the highest and the second highest Primary completion rate (% of total enrollments) in Ghana?
Provide a short and direct response. 8.31. What is the difference between the highest and the second highest Primary completion rate (% of total enrollments) in Turkey?
Keep it short and to the point. 3.42. What is the difference between the highest and the lowest Primary completion rate (% of total enrollments) of Low & middle income?
Your answer should be compact. 6.51. What is the difference between the highest and the lowest Primary completion rate (% of total enrollments) of Sub-Saharan Africa (developing only)?
Your answer should be compact. 8.47. What is the difference between the highest and the lowest Primary completion rate (% of total enrollments) of Ghana?
Give a very brief answer. 20.65. What is the difference between the highest and the lowest Primary completion rate (% of total enrollments) in Turkey?
Offer a very short reply. 7.09. 